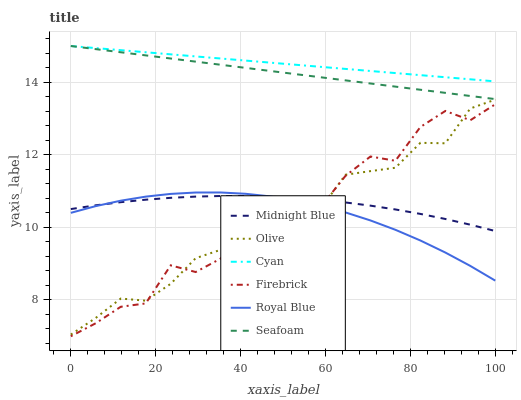Does Olive have the minimum area under the curve?
Answer yes or no. Yes. Does Cyan have the maximum area under the curve?
Answer yes or no. Yes. Does Firebrick have the minimum area under the curve?
Answer yes or no. No. Does Firebrick have the maximum area under the curve?
Answer yes or no. No. Is Seafoam the smoothest?
Answer yes or no. Yes. Is Firebrick the roughest?
Answer yes or no. Yes. Is Firebrick the smoothest?
Answer yes or no. No. Is Seafoam the roughest?
Answer yes or no. No. Does Firebrick have the lowest value?
Answer yes or no. Yes. Does Seafoam have the lowest value?
Answer yes or no. No. Does Cyan have the highest value?
Answer yes or no. Yes. Does Firebrick have the highest value?
Answer yes or no. No. Is Olive less than Cyan?
Answer yes or no. Yes. Is Cyan greater than Midnight Blue?
Answer yes or no. Yes. Does Firebrick intersect Royal Blue?
Answer yes or no. Yes. Is Firebrick less than Royal Blue?
Answer yes or no. No. Is Firebrick greater than Royal Blue?
Answer yes or no. No. Does Olive intersect Cyan?
Answer yes or no. No. 